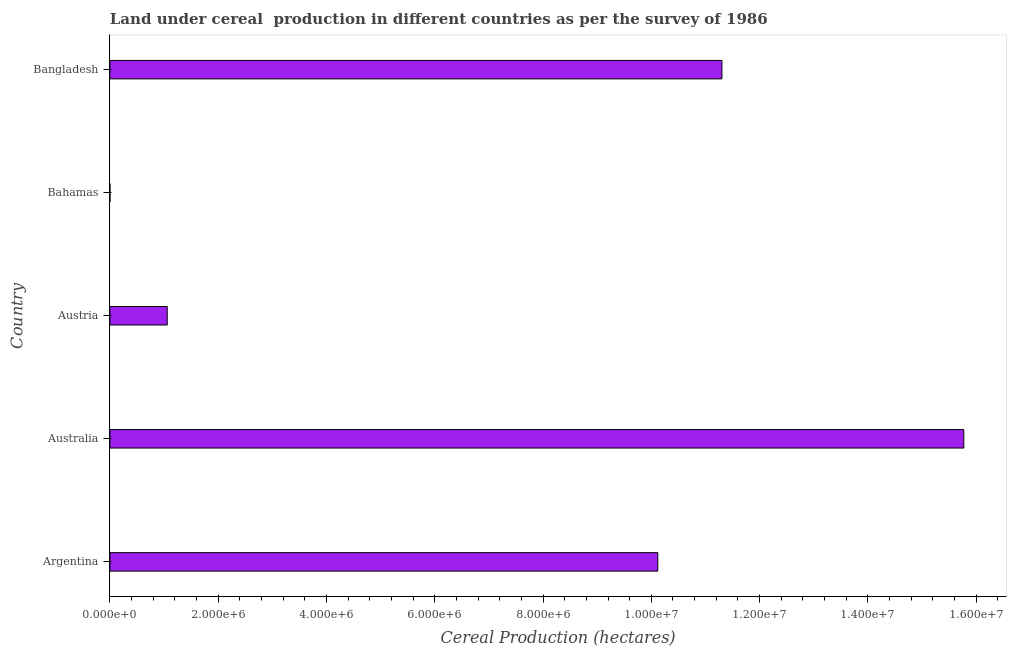Does the graph contain grids?
Your answer should be very brief. No. What is the title of the graph?
Provide a succinct answer. Land under cereal  production in different countries as per the survey of 1986. What is the label or title of the X-axis?
Make the answer very short. Cereal Production (hectares). What is the land under cereal production in Bangladesh?
Provide a short and direct response. 1.13e+07. Across all countries, what is the maximum land under cereal production?
Give a very brief answer. 1.58e+07. Across all countries, what is the minimum land under cereal production?
Ensure brevity in your answer.  610. In which country was the land under cereal production maximum?
Your answer should be very brief. Australia. In which country was the land under cereal production minimum?
Your answer should be very brief. Bahamas. What is the sum of the land under cereal production?
Your response must be concise. 3.83e+07. What is the difference between the land under cereal production in Argentina and Australia?
Your answer should be compact. -5.65e+06. What is the average land under cereal production per country?
Give a very brief answer. 7.65e+06. What is the median land under cereal production?
Your answer should be very brief. 1.01e+07. What is the ratio of the land under cereal production in Argentina to that in Bahamas?
Keep it short and to the point. 1.66e+04. What is the difference between the highest and the second highest land under cereal production?
Your answer should be compact. 4.47e+06. What is the difference between the highest and the lowest land under cereal production?
Offer a very short reply. 1.58e+07. How many bars are there?
Make the answer very short. 5. Are the values on the major ticks of X-axis written in scientific E-notation?
Ensure brevity in your answer.  Yes. What is the Cereal Production (hectares) in Argentina?
Give a very brief answer. 1.01e+07. What is the Cereal Production (hectares) of Australia?
Your response must be concise. 1.58e+07. What is the Cereal Production (hectares) in Austria?
Keep it short and to the point. 1.06e+06. What is the Cereal Production (hectares) of Bahamas?
Provide a succinct answer. 610. What is the Cereal Production (hectares) of Bangladesh?
Provide a succinct answer. 1.13e+07. What is the difference between the Cereal Production (hectares) in Argentina and Australia?
Your response must be concise. -5.65e+06. What is the difference between the Cereal Production (hectares) in Argentina and Austria?
Offer a very short reply. 9.06e+06. What is the difference between the Cereal Production (hectares) in Argentina and Bahamas?
Give a very brief answer. 1.01e+07. What is the difference between the Cereal Production (hectares) in Argentina and Bangladesh?
Make the answer very short. -1.18e+06. What is the difference between the Cereal Production (hectares) in Australia and Austria?
Ensure brevity in your answer.  1.47e+07. What is the difference between the Cereal Production (hectares) in Australia and Bahamas?
Provide a short and direct response. 1.58e+07. What is the difference between the Cereal Production (hectares) in Australia and Bangladesh?
Keep it short and to the point. 4.47e+06. What is the difference between the Cereal Production (hectares) in Austria and Bahamas?
Provide a short and direct response. 1.06e+06. What is the difference between the Cereal Production (hectares) in Austria and Bangladesh?
Ensure brevity in your answer.  -1.02e+07. What is the difference between the Cereal Production (hectares) in Bahamas and Bangladesh?
Provide a short and direct response. -1.13e+07. What is the ratio of the Cereal Production (hectares) in Argentina to that in Australia?
Provide a succinct answer. 0.64. What is the ratio of the Cereal Production (hectares) in Argentina to that in Austria?
Your answer should be very brief. 9.56. What is the ratio of the Cereal Production (hectares) in Argentina to that in Bahamas?
Make the answer very short. 1.66e+04. What is the ratio of the Cereal Production (hectares) in Argentina to that in Bangladesh?
Offer a very short reply. 0.9. What is the ratio of the Cereal Production (hectares) in Australia to that in Austria?
Keep it short and to the point. 14.9. What is the ratio of the Cereal Production (hectares) in Australia to that in Bahamas?
Make the answer very short. 2.59e+04. What is the ratio of the Cereal Production (hectares) in Australia to that in Bangladesh?
Make the answer very short. 1.4. What is the ratio of the Cereal Production (hectares) in Austria to that in Bahamas?
Your answer should be very brief. 1735.66. What is the ratio of the Cereal Production (hectares) in Austria to that in Bangladesh?
Provide a succinct answer. 0.09. 